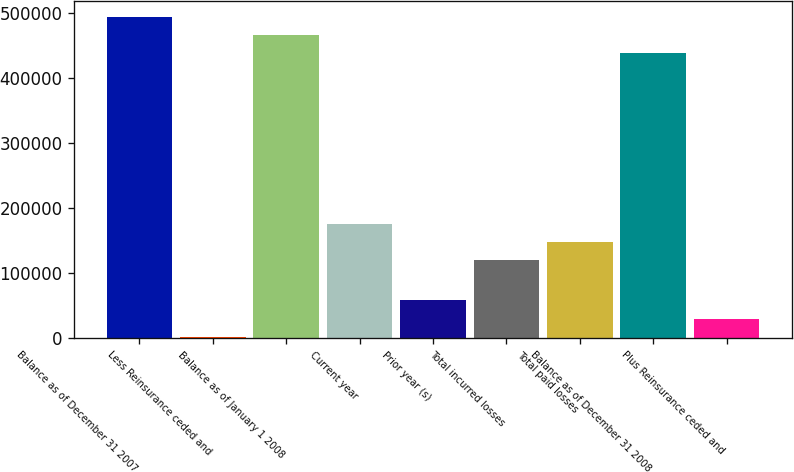Convert chart to OTSL. <chart><loc_0><loc_0><loc_500><loc_500><bar_chart><fcel>Balance as of December 31 2007<fcel>Less Reinsurance ceded and<fcel>Balance as of January 1 2008<fcel>Current year<fcel>Prior year (s)<fcel>Total incurred losses<fcel>Total paid losses<fcel>Balance as of December 31 2008<fcel>Plus Reinsurance ceded and<nl><fcel>494703<fcel>1350<fcel>466733<fcel>175644<fcel>58480<fcel>119705<fcel>147674<fcel>438764<fcel>29319.3<nl></chart> 